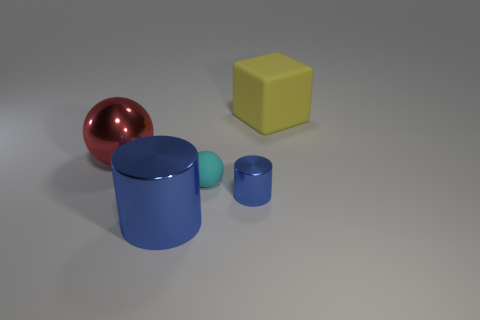Add 4 tiny blue objects. How many objects exist? 9 Subtract 1 cylinders. How many cylinders are left? 1 Subtract all cubes. How many objects are left? 4 Add 2 blue metallic cylinders. How many blue metallic cylinders exist? 4 Subtract all red spheres. How many spheres are left? 1 Subtract 1 cyan balls. How many objects are left? 4 Subtract all gray balls. Subtract all brown blocks. How many balls are left? 2 Subtract all small red cylinders. Subtract all tiny cyan spheres. How many objects are left? 4 Add 4 cyan things. How many cyan things are left? 5 